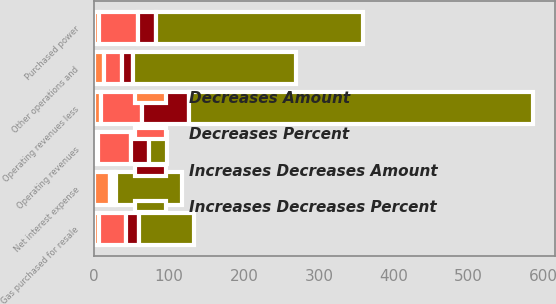Convert chart. <chart><loc_0><loc_0><loc_500><loc_500><stacked_bar_chart><ecel><fcel>Operating revenues<fcel>Purchased power<fcel>Gas purchased for resale<fcel>Operating revenues less<fcel>Other operations and<fcel>Net interest expense<nl><fcel>Increases Decreases Percent<fcel>23.8<fcel>276<fcel>73<fcel>459<fcel>218<fcel>88<nl><fcel>Decreases Amount<fcel>5.5<fcel>5.9<fcel>6.3<fcel>9.4<fcel>13.1<fcel>20.9<nl><fcel>Increases Decreases Amount<fcel>23.8<fcel>23.8<fcel>17<fcel>63<fcel>15<fcel>2<nl><fcel>Decreases Percent<fcel>43.7<fcel>52.9<fcel>36.2<fcel>53.8<fcel>23.8<fcel>5.9<nl></chart> 